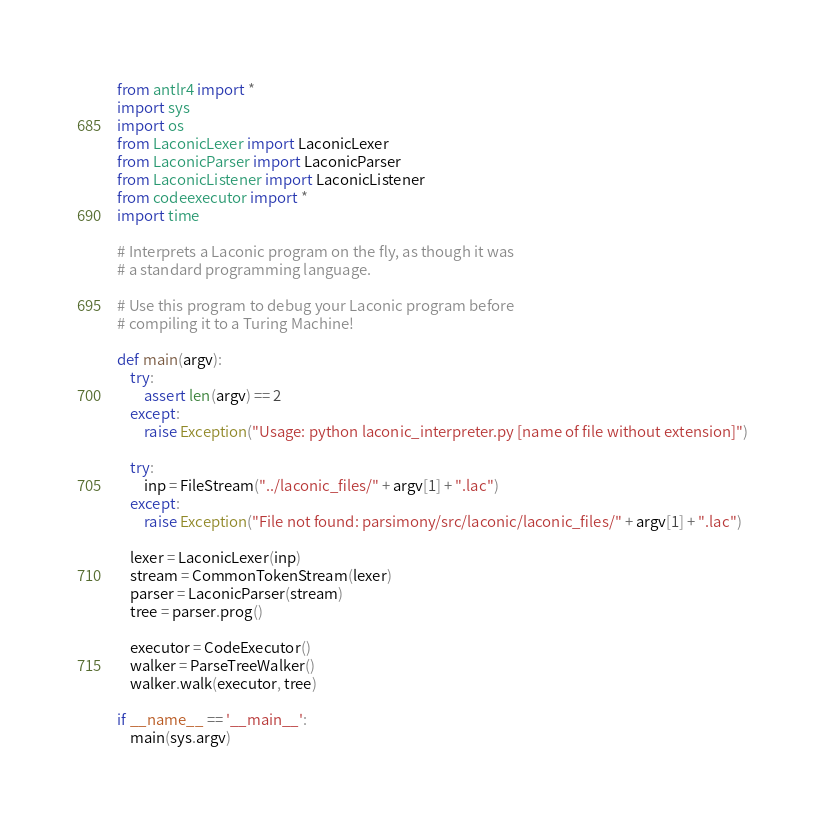Convert code to text. <code><loc_0><loc_0><loc_500><loc_500><_Python_>from antlr4 import *
import sys
import os
from LaconicLexer import LaconicLexer
from LaconicParser import LaconicParser
from LaconicListener import LaconicListener
from codeexecutor import *
import time

# Interprets a Laconic program on the fly, as though it was 
# a standard programming language. 

# Use this program to debug your Laconic program before 
# compiling it to a Turing Machine!

def main(argv):
    try:
        assert len(argv) == 2
    except:
        raise Exception("Usage: python laconic_interpreter.py [name of file without extension]")
    
    try:
        inp = FileStream("../laconic_files/" + argv[1] + ".lac")
    except:
        raise Exception("File not found: parsimony/src/laconic/laconic_files/" + argv[1] + ".lac")
        
    lexer = LaconicLexer(inp)
    stream = CommonTokenStream(lexer)
    parser = LaconicParser(stream)
    tree = parser.prog()

    executor = CodeExecutor()
    walker = ParseTreeWalker()
    walker.walk(executor, tree)

if __name__ == '__main__':
    main(sys.argv)
</code> 